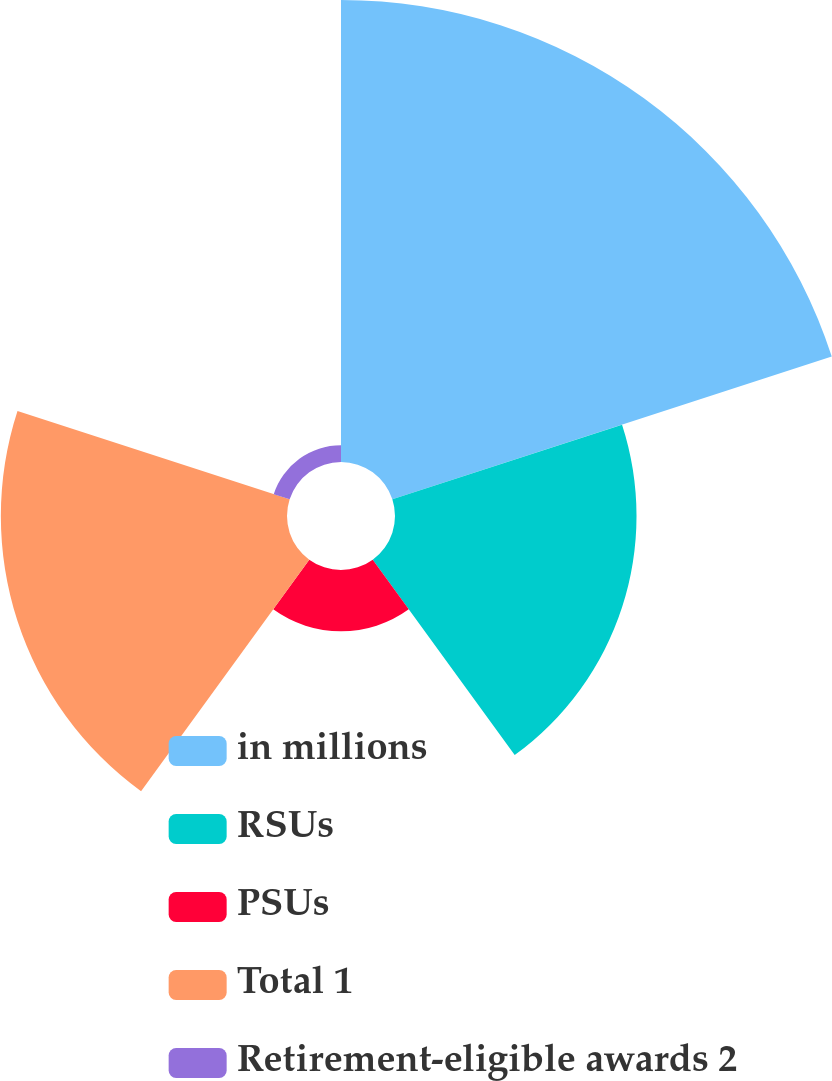<chart> <loc_0><loc_0><loc_500><loc_500><pie_chart><fcel>in millions<fcel>RSUs<fcel>PSUs<fcel>Total 1<fcel>Retirement-eligible awards 2<nl><fcel>43.27%<fcel>22.62%<fcel>5.74%<fcel>26.8%<fcel>1.57%<nl></chart> 